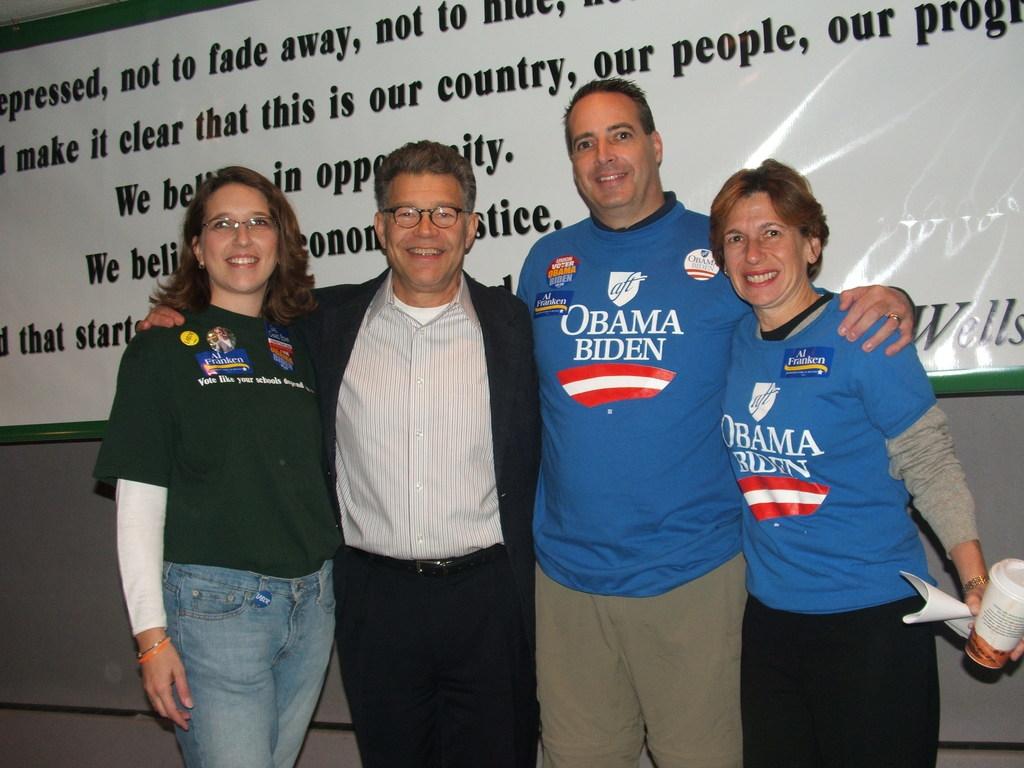Who's name is written on their buttons?
Offer a very short reply. Obama. 